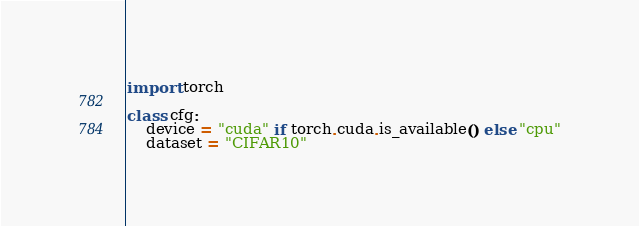<code> <loc_0><loc_0><loc_500><loc_500><_Python_>import torch

class cfg:
    device = "cuda" if torch.cuda.is_available() else "cpu"
    dataset = "CIFAR10"</code> 